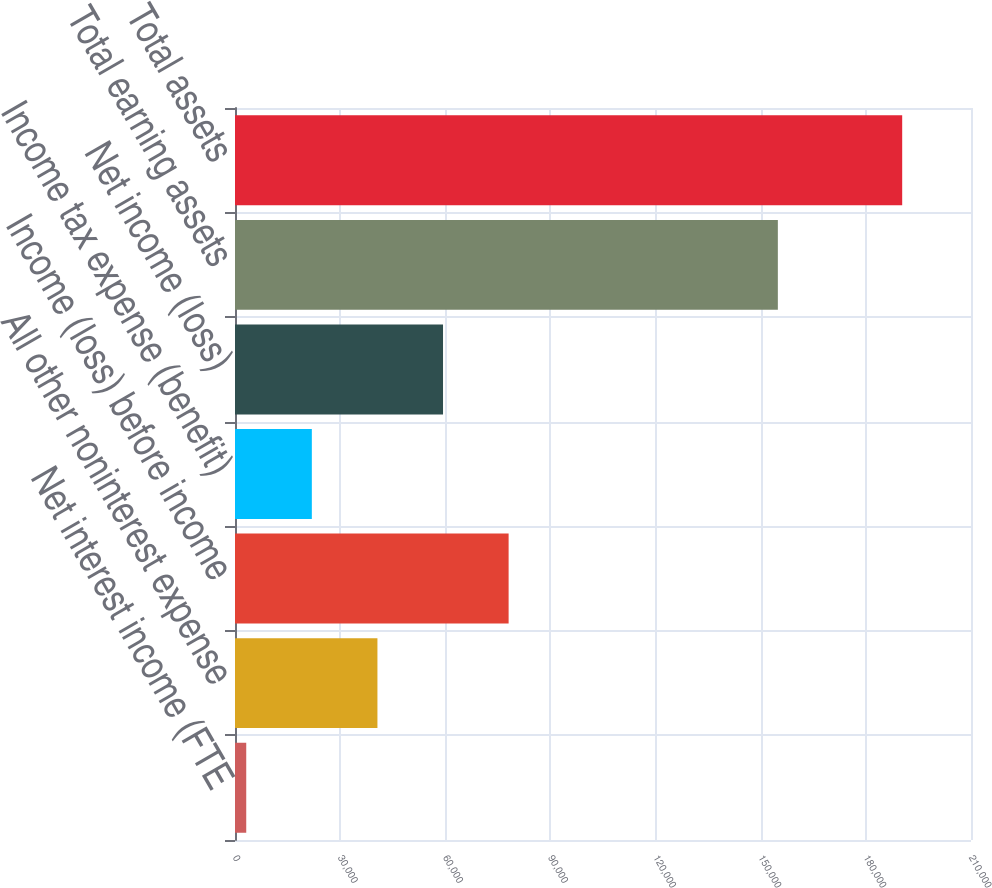<chart> <loc_0><loc_0><loc_500><loc_500><bar_chart><fcel>Net interest income (FTE<fcel>All other noninterest expense<fcel>Income (loss) before income<fcel>Income tax expense (benefit)<fcel>Net income (loss)<fcel>Total earning assets<fcel>Total assets<nl><fcel>3207<fcel>40639<fcel>78071<fcel>21923<fcel>59355<fcel>154890<fcel>190367<nl></chart> 